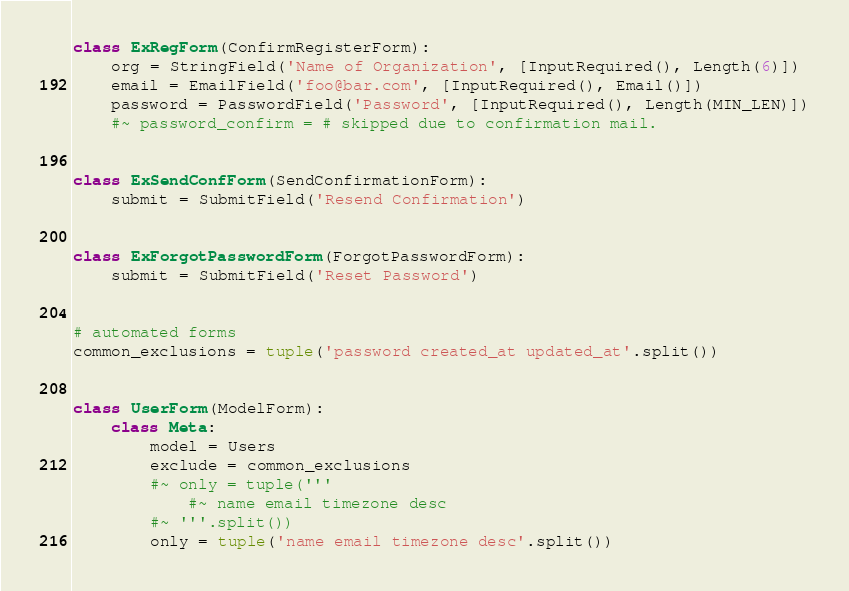Convert code to text. <code><loc_0><loc_0><loc_500><loc_500><_Python_>
class ExRegForm(ConfirmRegisterForm):
    org = StringField('Name of Organization', [InputRequired(), Length(6)])
    email = EmailField('foo@bar.com', [InputRequired(), Email()])
    password = PasswordField('Password', [InputRequired(), Length(MIN_LEN)])
    #~ password_confirm = # skipped due to confirmation mail.


class ExSendConfForm(SendConfirmationForm):
    submit = SubmitField('Resend Confirmation')


class ExForgotPasswordForm(ForgotPasswordForm):
    submit = SubmitField('Reset Password')


# automated forms
common_exclusions = tuple('password created_at updated_at'.split())


class UserForm(ModelForm):
    class Meta:
        model = Users
        exclude = common_exclusions
        #~ only = tuple('''
            #~ name email timezone desc
        #~ '''.split())
        only = tuple('name email timezone desc'.split())
</code> 